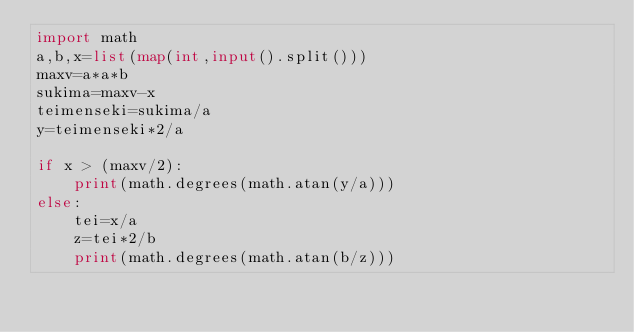Convert code to text. <code><loc_0><loc_0><loc_500><loc_500><_Python_>import math
a,b,x=list(map(int,input().split()))
maxv=a*a*b
sukima=maxv-x
teimenseki=sukima/a
y=teimenseki*2/a
 
if x > (maxv/2):
    print(math.degrees(math.atan(y/a)))
else:
    tei=x/a
    z=tei*2/b
    print(math.degrees(math.atan(b/z)))</code> 